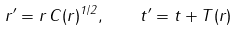<formula> <loc_0><loc_0><loc_500><loc_500>r ^ { \prime } = r \, C ( r ) ^ { 1 / 2 } , \quad t ^ { \prime } = t + T ( r )</formula> 